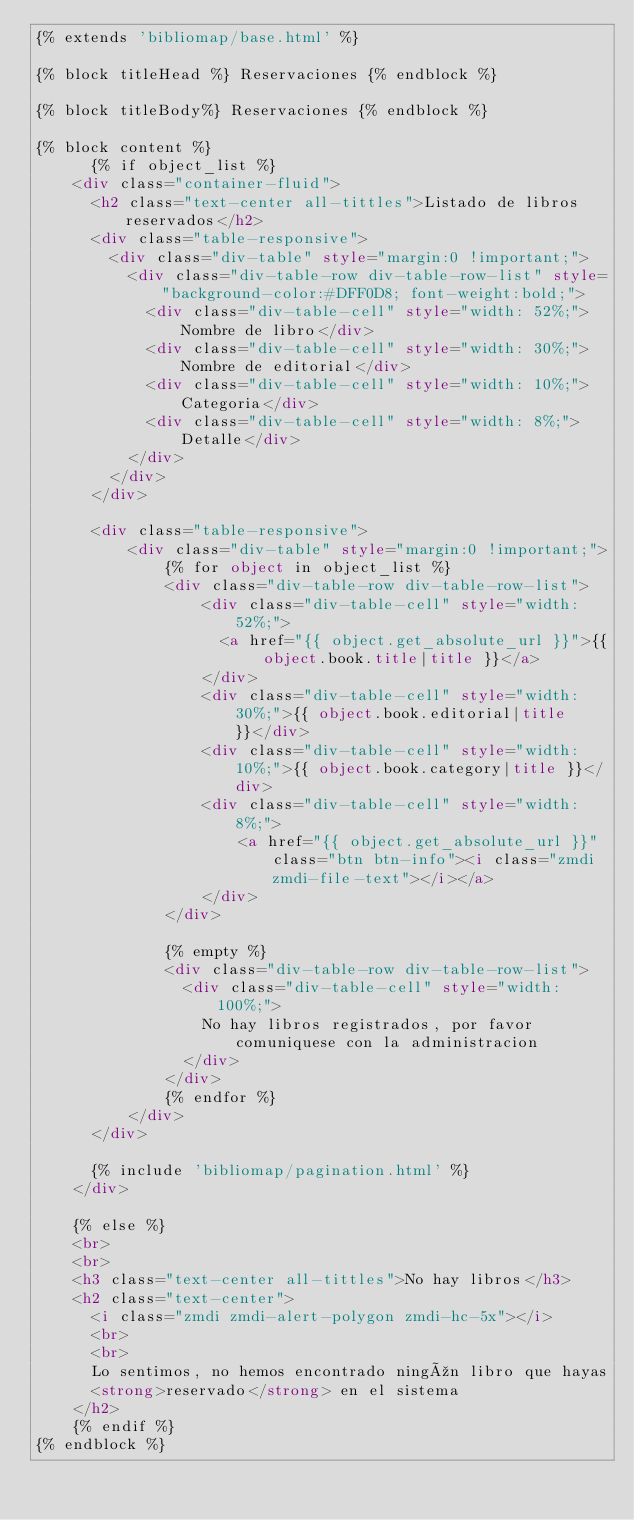Convert code to text. <code><loc_0><loc_0><loc_500><loc_500><_HTML_>{% extends 'bibliomap/base.html' %}

{% block titleHead %} Reservaciones {% endblock %}

{% block titleBody%} Reservaciones {% endblock %}

{% block content %}
	  {% if object_list %}
    <div class="container-fluid">
      <h2 class="text-center all-tittles">Listado de libros reservados</h2>
      <div class="table-responsive">
        <div class="div-table" style="margin:0 !important;">
          <div class="div-table-row div-table-row-list" style="background-color:#DFF0D8; font-weight:bold;">
            <div class="div-table-cell" style="width: 52%;">Nombre de libro</div>
            <div class="div-table-cell" style="width: 30%;">Nombre de editorial</div>
            <div class="div-table-cell" style="width: 10%;">Categoria</div>
            <div class="div-table-cell" style="width: 8%;">Detalle</div>
          </div>
        </div>
      </div>

      <div class="table-responsive">
          <div class="div-table" style="margin:0 !important;">
              {% for object in object_list %}
              <div class="div-table-row div-table-row-list">
                  <div class="div-table-cell" style="width: 52%;">
                    <a href="{{ object.get_absolute_url }}">{{ object.book.title|title }}</a>
                  </div>
                  <div class="div-table-cell" style="width: 30%;">{{ object.book.editorial|title }}</div>
                  <div class="div-table-cell" style="width: 10%;">{{ object.book.category|title }}</div>
                  <div class="div-table-cell" style="width: 8%;">
                      <a href="{{ object.get_absolute_url }}" class="btn btn-info"><i class="zmdi zmdi-file-text"></i></a>
                  </div>
              </div>

              {% empty %}
              <div class="div-table-row div-table-row-list">
                <div class="div-table-cell" style="width: 100%;">
                  No hay libros registrados, por favor comuniquese con la administracion
                </div>
              </div>
              {% endfor %}
          </div>
      </div>
      
      {% include 'bibliomap/pagination.html' %}
    </div>

    {% else %}
    <br>
    <br>
    <h3 class="text-center all-tittles">No hay libros</h3>
    <h2 class="text-center">
      <i class="zmdi zmdi-alert-polygon zmdi-hc-5x"></i>
      <br>
      <br>
      Lo sentimos, no hemos encontrado ningún libro que hayas
      <strong>reservado</strong> en el sistema
    </h2>
	{% endif %}
{% endblock %}</code> 